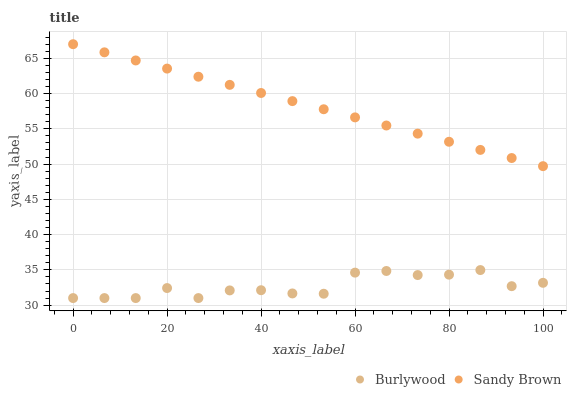Does Burlywood have the minimum area under the curve?
Answer yes or no. Yes. Does Sandy Brown have the maximum area under the curve?
Answer yes or no. Yes. Does Sandy Brown have the minimum area under the curve?
Answer yes or no. No. Is Sandy Brown the smoothest?
Answer yes or no. Yes. Is Burlywood the roughest?
Answer yes or no. Yes. Is Sandy Brown the roughest?
Answer yes or no. No. Does Burlywood have the lowest value?
Answer yes or no. Yes. Does Sandy Brown have the lowest value?
Answer yes or no. No. Does Sandy Brown have the highest value?
Answer yes or no. Yes. Is Burlywood less than Sandy Brown?
Answer yes or no. Yes. Is Sandy Brown greater than Burlywood?
Answer yes or no. Yes. Does Burlywood intersect Sandy Brown?
Answer yes or no. No. 